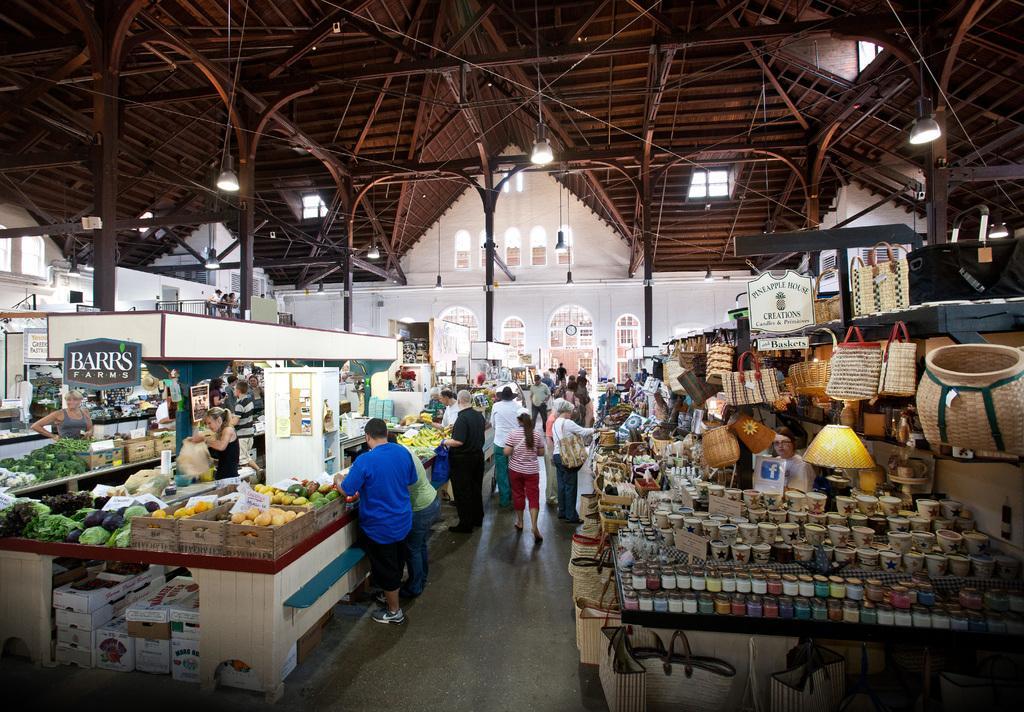In one or two sentences, can you explain what this image depicts? This is the picture of a building. On the left side of the image there are vegetables and fruits on the table and there are cardboard boxes and there is a board and there is text on the board. On the right side of the image there are cups, bottles, bags and baskets and there is a board and there is text on the board and there are group of people standing. At the back there are doors and windows. At the top there are lights. At the bottom there is a floor. 